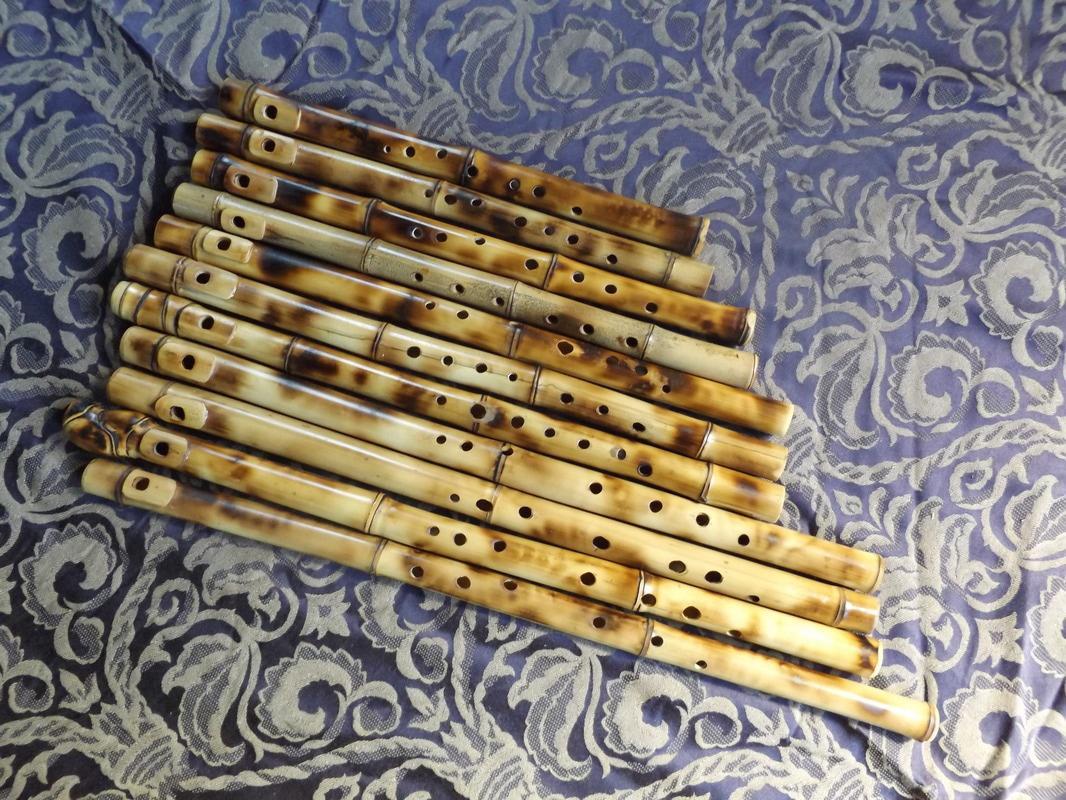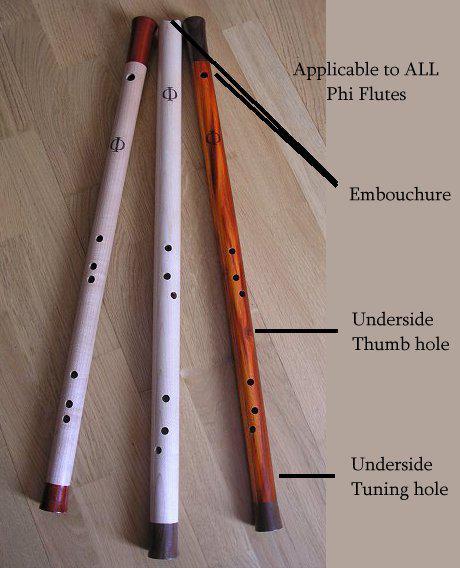The first image is the image on the left, the second image is the image on the right. Analyze the images presented: Is the assertion "One image shows three flutes side by side, with their ends closer together at the top of the image." valid? Answer yes or no. Yes. The first image is the image on the left, the second image is the image on the right. For the images shown, is this caption "One of the images contains exactly three flutes." true? Answer yes or no. Yes. 